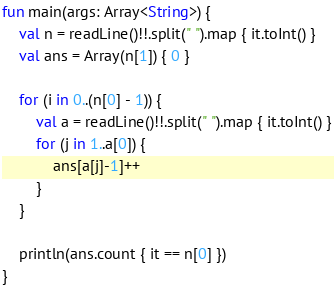<code> <loc_0><loc_0><loc_500><loc_500><_Kotlin_>fun main(args: Array<String>) {
    val n = readLine()!!.split(" ").map { it.toInt() }
    val ans = Array(n[1]) { 0 }

    for (i in 0..(n[0] - 1)) {
        val a = readLine()!!.split(" ").map { it.toInt() }
        for (j in 1..a[0]) {
            ans[a[j]-1]++
        }
    }

    println(ans.count { it == n[0] })
}</code> 